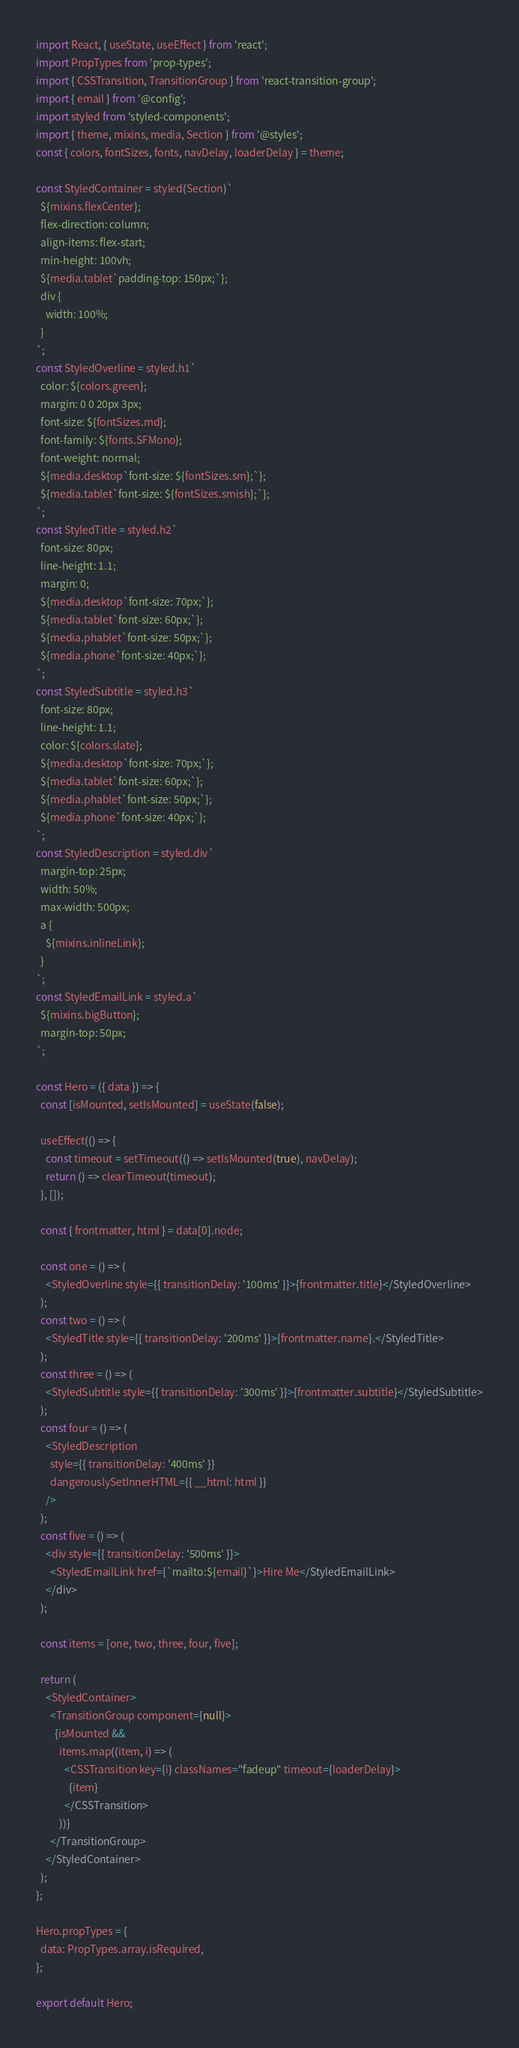<code> <loc_0><loc_0><loc_500><loc_500><_JavaScript_>import React, { useState, useEffect } from 'react';
import PropTypes from 'prop-types';
import { CSSTransition, TransitionGroup } from 'react-transition-group';
import { email } from '@config';
import styled from 'styled-components';
import { theme, mixins, media, Section } from '@styles';
const { colors, fontSizes, fonts, navDelay, loaderDelay } = theme;

const StyledContainer = styled(Section)`
  ${mixins.flexCenter};
  flex-direction: column;
  align-items: flex-start;
  min-height: 100vh;
  ${media.tablet`padding-top: 150px;`};
  div {
    width: 100%;
  }
`;
const StyledOverline = styled.h1`
  color: ${colors.green};
  margin: 0 0 20px 3px;
  font-size: ${fontSizes.md};
  font-family: ${fonts.SFMono};
  font-weight: normal;
  ${media.desktop`font-size: ${fontSizes.sm};`};
  ${media.tablet`font-size: ${fontSizes.smish};`};
`;
const StyledTitle = styled.h2`
  font-size: 80px;
  line-height: 1.1;
  margin: 0;
  ${media.desktop`font-size: 70px;`};
  ${media.tablet`font-size: 60px;`};
  ${media.phablet`font-size: 50px;`};
  ${media.phone`font-size: 40px;`};
`;
const StyledSubtitle = styled.h3`
  font-size: 80px;
  line-height: 1.1;
  color: ${colors.slate};
  ${media.desktop`font-size: 70px;`};
  ${media.tablet`font-size: 60px;`};
  ${media.phablet`font-size: 50px;`};
  ${media.phone`font-size: 40px;`};
`;
const StyledDescription = styled.div`
  margin-top: 25px;
  width: 50%;
  max-width: 500px;
  a {
    ${mixins.inlineLink};
  }
`;
const StyledEmailLink = styled.a`
  ${mixins.bigButton};
  margin-top: 50px;
`;

const Hero = ({ data }) => {
  const [isMounted, setIsMounted] = useState(false);

  useEffect(() => {
    const timeout = setTimeout(() => setIsMounted(true), navDelay);
    return () => clearTimeout(timeout);
  }, []);

  const { frontmatter, html } = data[0].node;

  const one = () => (
    <StyledOverline style={{ transitionDelay: '100ms' }}>{frontmatter.title}</StyledOverline>
  );
  const two = () => (
    <StyledTitle style={{ transitionDelay: '200ms' }}>{frontmatter.name}.</StyledTitle>
  );
  const three = () => (
    <StyledSubtitle style={{ transitionDelay: '300ms' }}>{frontmatter.subtitle}</StyledSubtitle>
  );
  const four = () => (
    <StyledDescription
      style={{ transitionDelay: '400ms' }}
      dangerouslySetInnerHTML={{ __html: html }}
    />
  );
  const five = () => (
    <div style={{ transitionDelay: '500ms' }}>
      <StyledEmailLink href={`mailto:${email}`}>Hire Me</StyledEmailLink>
    </div>
  );

  const items = [one, two, three, four, five];

  return (
    <StyledContainer>
      <TransitionGroup component={null}>
        {isMounted &&
          items.map((item, i) => (
            <CSSTransition key={i} classNames="fadeup" timeout={loaderDelay}>
              {item}
            </CSSTransition>
          ))}
      </TransitionGroup>
    </StyledContainer>
  );
};

Hero.propTypes = {
  data: PropTypes.array.isRequired,
};

export default Hero;
</code> 